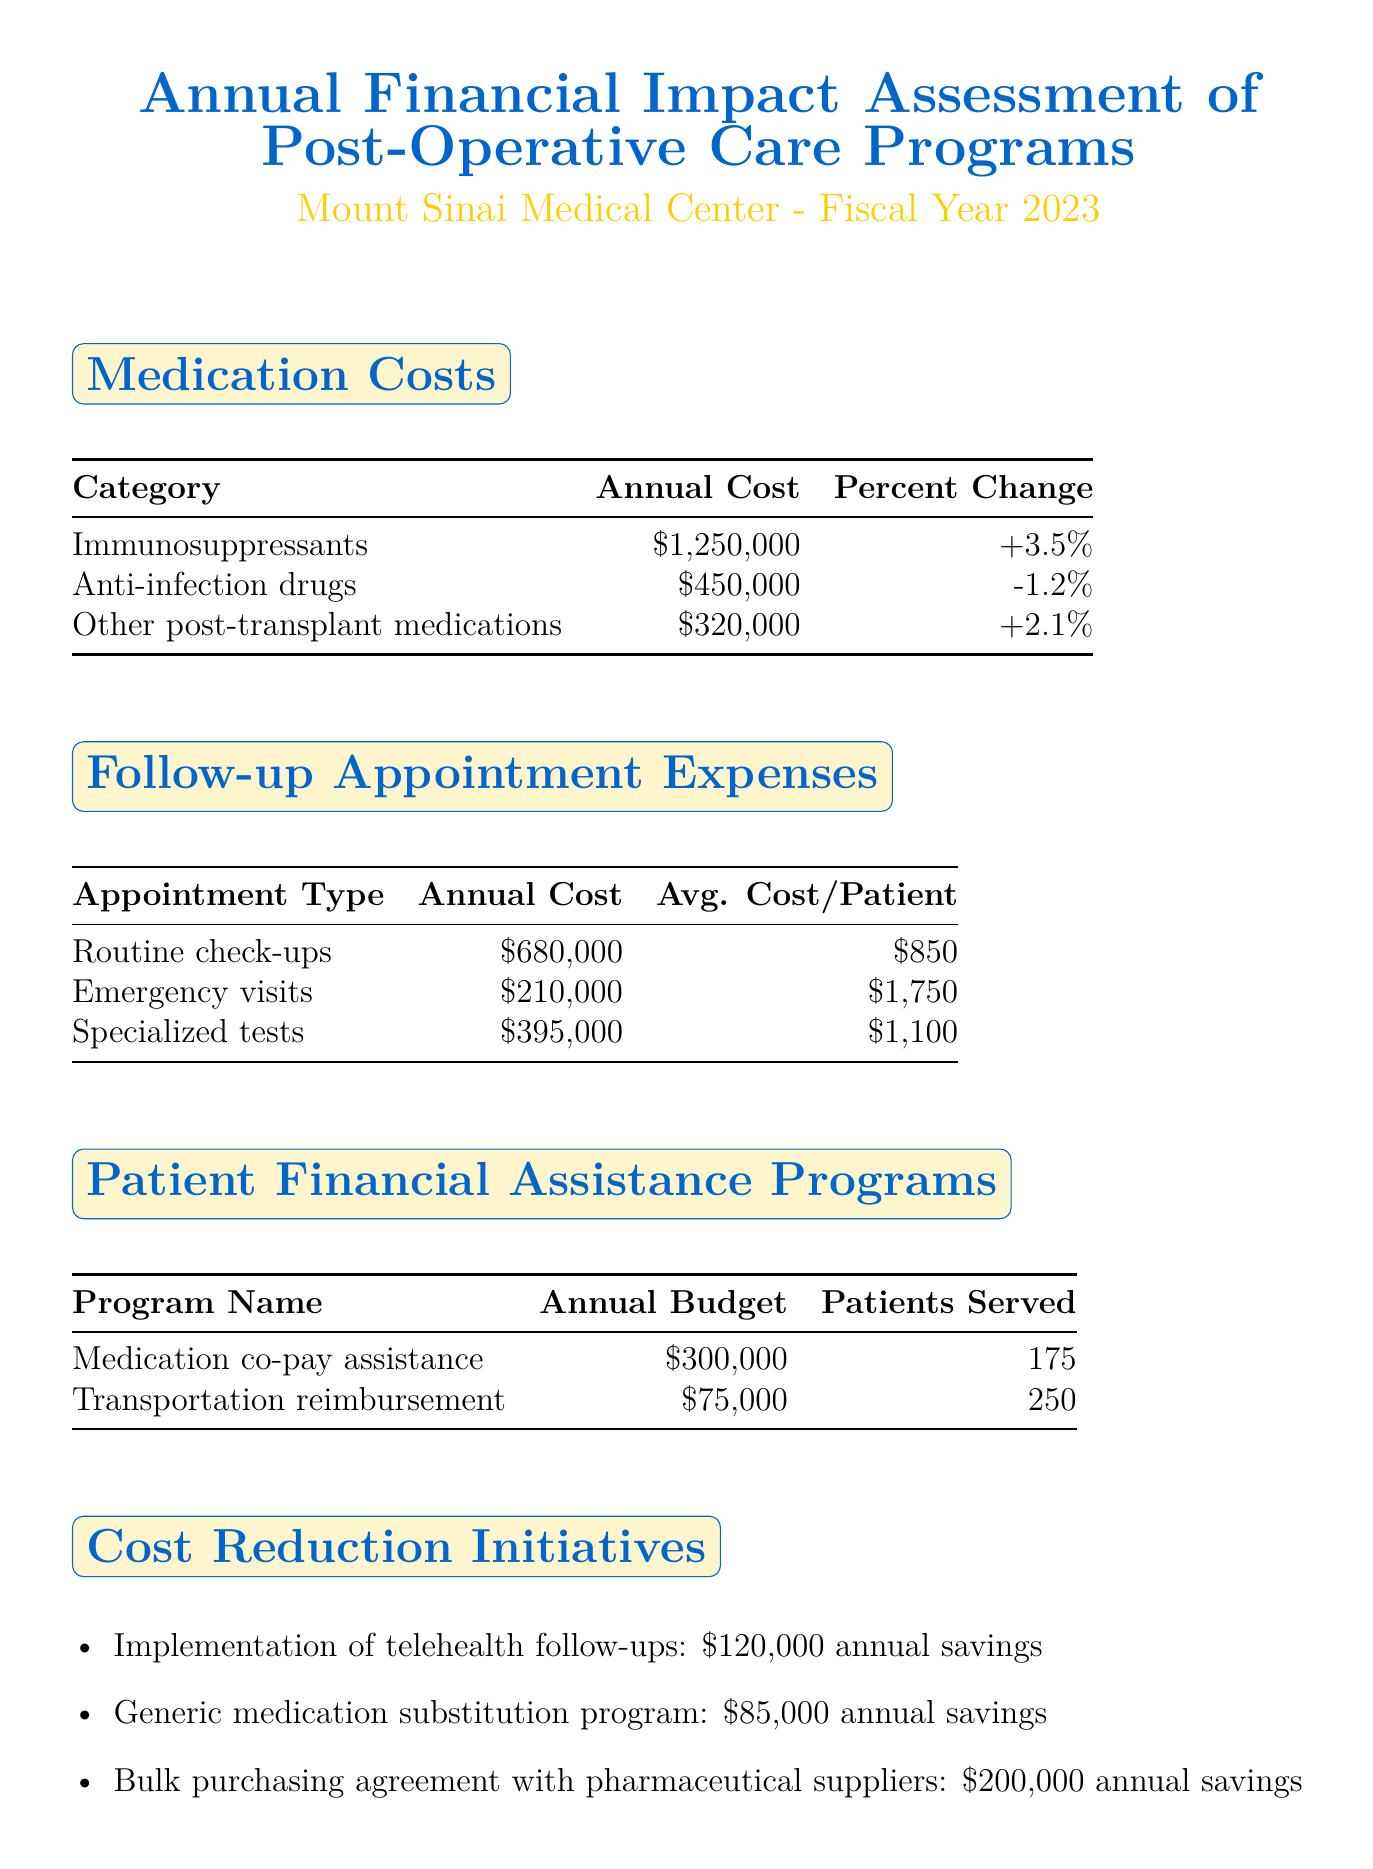What is the annual cost of immunosuppressants? The annual cost of immunosuppressants is listed in the Medication Costs section as $1,250,000.
Answer: $1,250,000 What is the percent change for anti-infection drugs? The percent change for anti-infection drugs is indicated in the Medication Costs section as -1.2%.
Answer: -1.2% What is the average cost per patient for routine check-ups? The average cost per patient for routine check-ups is provided in the Follow-up Appointment Expenses section as $850.
Answer: $850 How much is the annual budget for transportation reimbursement? The annual budget for transportation reimbursement is specified in the Patient Financial Assistance Programs section as $75,000.
Answer: $75,000 What is the annual savings from the bulk purchasing agreement? The document states that the bulk purchasing agreement with pharmaceutical suppliers results in $200,000 annual savings under Cost Reduction Initiatives.
Answer: $200,000 How many patients are served by the medication co-pay assistance program? The number of patients served by the medication co-pay assistance program is mentioned as 175 in the Patient Financial Assistance Programs section.
Answer: 175 What is the average cost per patient per year according to the Key Performance Indicators? The average cost per patient per year is highlighted as $22,500 in the Key Performance Indicators section.
Answer: $22,500 What is the medication adherence rate? The medication adherence rate is indicated as 92% within the Key Performance Indicators section.
Answer: 92% How much did the implementation of telehealth follow-ups save annually? The telehealth follow-ups initiative is noted to save $120,000 annually in the Cost Reduction Initiatives section.
Answer: $120,000 